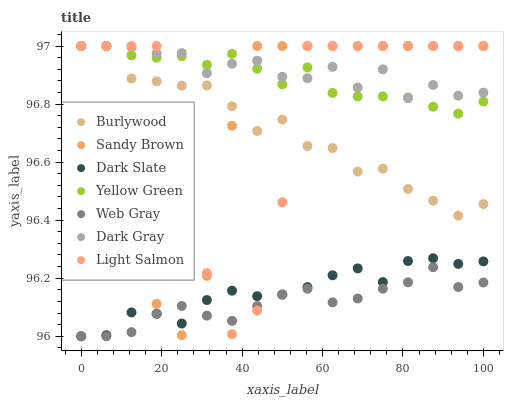Does Web Gray have the minimum area under the curve?
Answer yes or no. Yes. Does Dark Gray have the maximum area under the curve?
Answer yes or no. Yes. Does Yellow Green have the minimum area under the curve?
Answer yes or no. No. Does Yellow Green have the maximum area under the curve?
Answer yes or no. No. Is Web Gray the smoothest?
Answer yes or no. Yes. Is Light Salmon the roughest?
Answer yes or no. Yes. Is Yellow Green the smoothest?
Answer yes or no. No. Is Yellow Green the roughest?
Answer yes or no. No. Does Web Gray have the lowest value?
Answer yes or no. Yes. Does Yellow Green have the lowest value?
Answer yes or no. No. Does Sandy Brown have the highest value?
Answer yes or no. Yes. Does Web Gray have the highest value?
Answer yes or no. No. Is Dark Slate less than Yellow Green?
Answer yes or no. Yes. Is Burlywood greater than Dark Slate?
Answer yes or no. Yes. Does Dark Slate intersect Light Salmon?
Answer yes or no. Yes. Is Dark Slate less than Light Salmon?
Answer yes or no. No. Is Dark Slate greater than Light Salmon?
Answer yes or no. No. Does Dark Slate intersect Yellow Green?
Answer yes or no. No. 